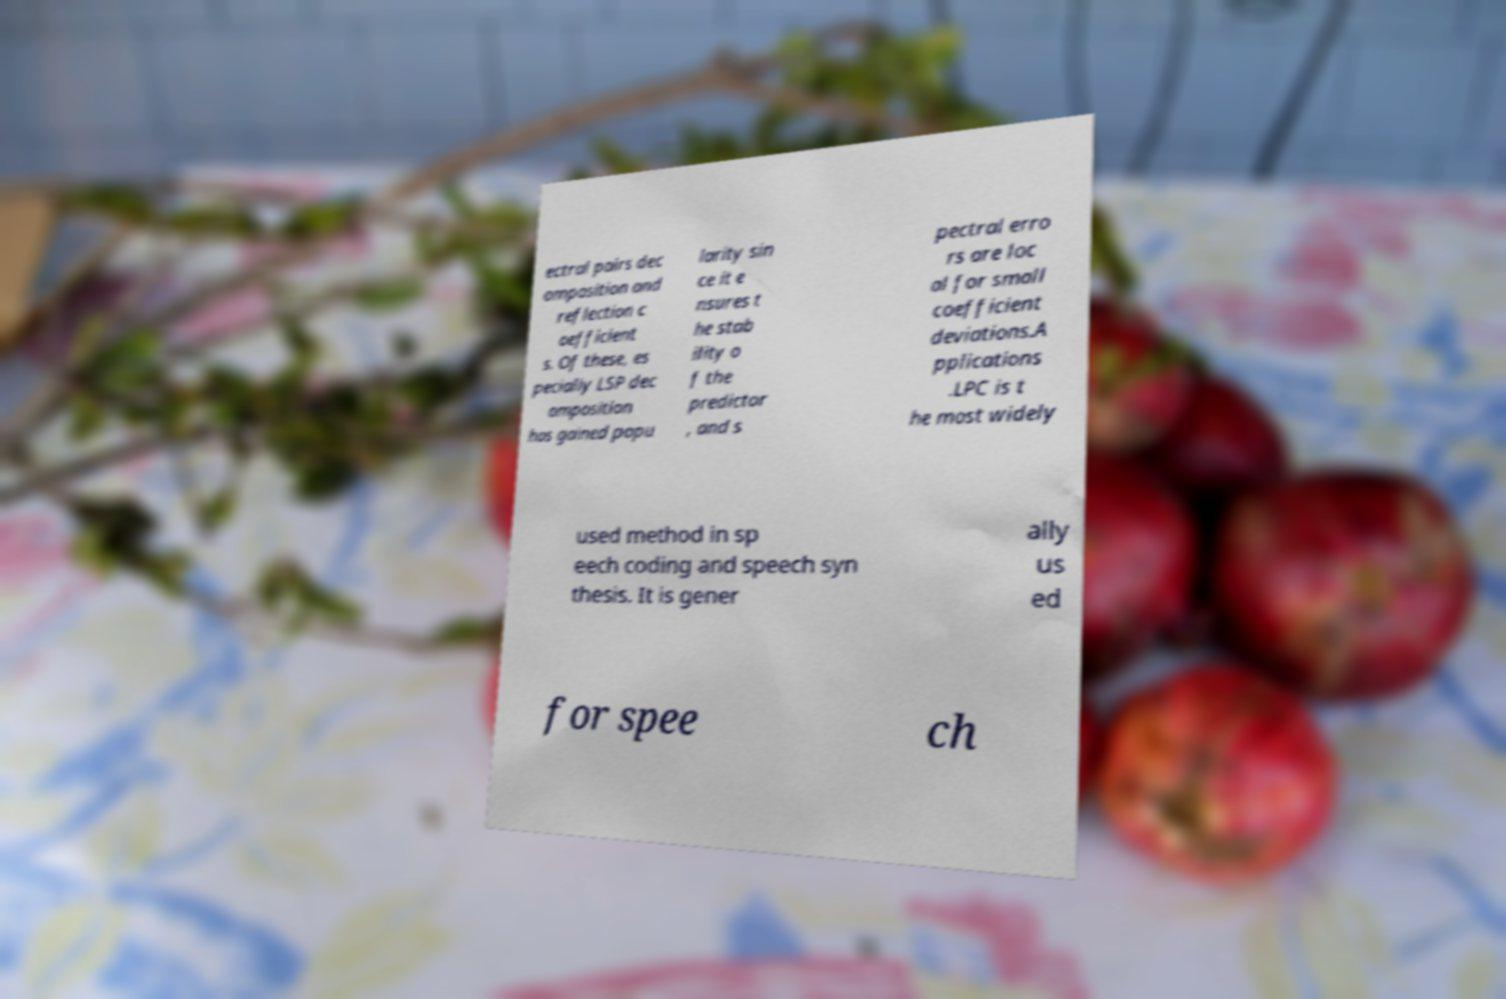Please identify and transcribe the text found in this image. ectral pairs dec omposition and reflection c oefficient s. Of these, es pecially LSP dec omposition has gained popu larity sin ce it e nsures t he stab ility o f the predictor , and s pectral erro rs are loc al for small coefficient deviations.A pplications .LPC is t he most widely used method in sp eech coding and speech syn thesis. It is gener ally us ed for spee ch 